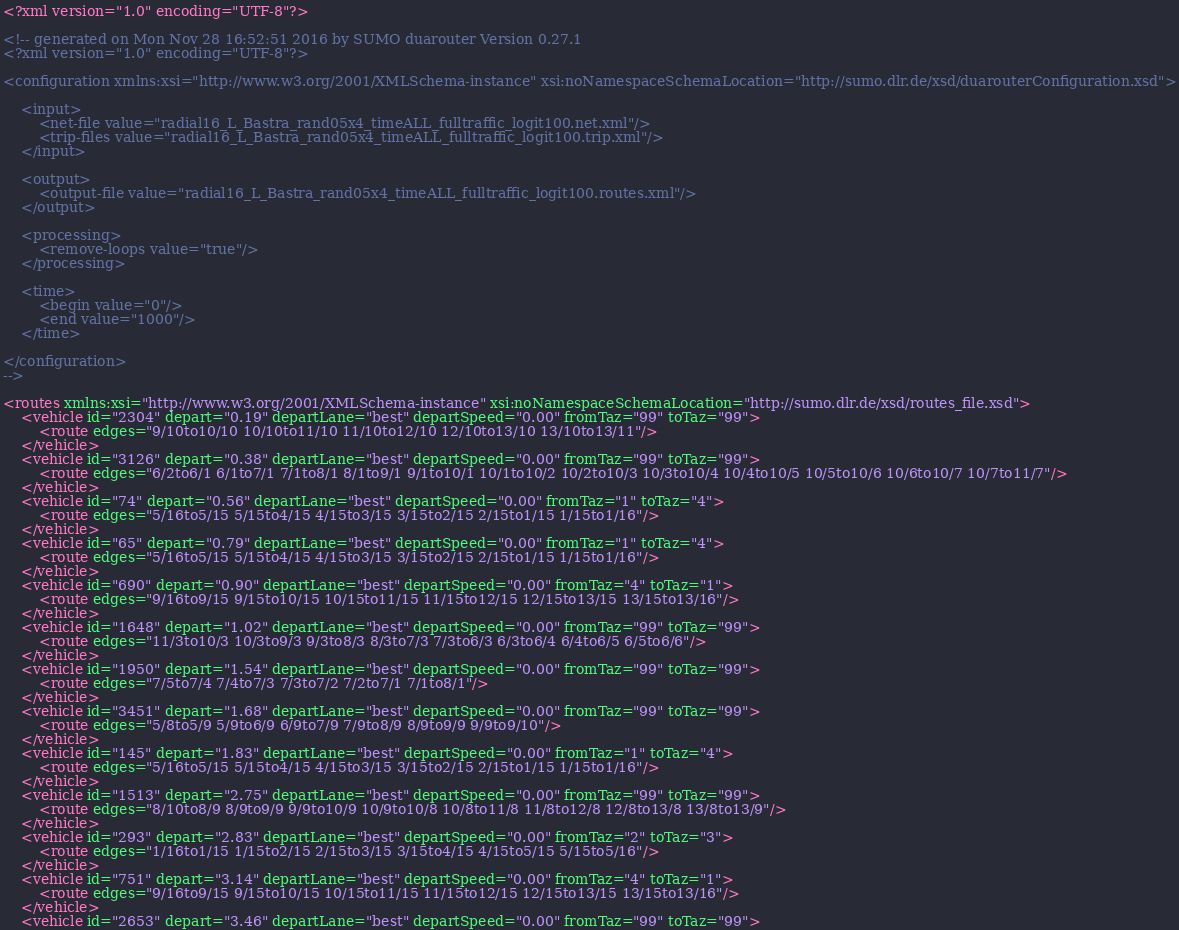Convert code to text. <code><loc_0><loc_0><loc_500><loc_500><_XML_><?xml version="1.0" encoding="UTF-8"?>

<!-- generated on Mon Nov 28 16:52:51 2016 by SUMO duarouter Version 0.27.1
<?xml version="1.0" encoding="UTF-8"?>

<configuration xmlns:xsi="http://www.w3.org/2001/XMLSchema-instance" xsi:noNamespaceSchemaLocation="http://sumo.dlr.de/xsd/duarouterConfiguration.xsd">

    <input>
        <net-file value="radial16_L_Bastra_rand05x4_timeALL_fulltraffic_logit100.net.xml"/>
        <trip-files value="radial16_L_Bastra_rand05x4_timeALL_fulltraffic_logit100.trip.xml"/>
    </input>

    <output>
        <output-file value="radial16_L_Bastra_rand05x4_timeALL_fulltraffic_logit100.routes.xml"/>
    </output>

    <processing>
        <remove-loops value="true"/>
    </processing>

    <time>
        <begin value="0"/>
        <end value="1000"/>
    </time>

</configuration>
-->

<routes xmlns:xsi="http://www.w3.org/2001/XMLSchema-instance" xsi:noNamespaceSchemaLocation="http://sumo.dlr.de/xsd/routes_file.xsd">
    <vehicle id="2304" depart="0.19" departLane="best" departSpeed="0.00" fromTaz="99" toTaz="99">
        <route edges="9/10to10/10 10/10to11/10 11/10to12/10 12/10to13/10 13/10to13/11"/>
    </vehicle>
    <vehicle id="3126" depart="0.38" departLane="best" departSpeed="0.00" fromTaz="99" toTaz="99">
        <route edges="6/2to6/1 6/1to7/1 7/1to8/1 8/1to9/1 9/1to10/1 10/1to10/2 10/2to10/3 10/3to10/4 10/4to10/5 10/5to10/6 10/6to10/7 10/7to11/7"/>
    </vehicle>
    <vehicle id="74" depart="0.56" departLane="best" departSpeed="0.00" fromTaz="1" toTaz="4">
        <route edges="5/16to5/15 5/15to4/15 4/15to3/15 3/15to2/15 2/15to1/15 1/15to1/16"/>
    </vehicle>
    <vehicle id="65" depart="0.79" departLane="best" departSpeed="0.00" fromTaz="1" toTaz="4">
        <route edges="5/16to5/15 5/15to4/15 4/15to3/15 3/15to2/15 2/15to1/15 1/15to1/16"/>
    </vehicle>
    <vehicle id="690" depart="0.90" departLane="best" departSpeed="0.00" fromTaz="4" toTaz="1">
        <route edges="9/16to9/15 9/15to10/15 10/15to11/15 11/15to12/15 12/15to13/15 13/15to13/16"/>
    </vehicle>
    <vehicle id="1648" depart="1.02" departLane="best" departSpeed="0.00" fromTaz="99" toTaz="99">
        <route edges="11/3to10/3 10/3to9/3 9/3to8/3 8/3to7/3 7/3to6/3 6/3to6/4 6/4to6/5 6/5to6/6"/>
    </vehicle>
    <vehicle id="1950" depart="1.54" departLane="best" departSpeed="0.00" fromTaz="99" toTaz="99">
        <route edges="7/5to7/4 7/4to7/3 7/3to7/2 7/2to7/1 7/1to8/1"/>
    </vehicle>
    <vehicle id="3451" depart="1.68" departLane="best" departSpeed="0.00" fromTaz="99" toTaz="99">
        <route edges="5/8to5/9 5/9to6/9 6/9to7/9 7/9to8/9 8/9to9/9 9/9to9/10"/>
    </vehicle>
    <vehicle id="145" depart="1.83" departLane="best" departSpeed="0.00" fromTaz="1" toTaz="4">
        <route edges="5/16to5/15 5/15to4/15 4/15to3/15 3/15to2/15 2/15to1/15 1/15to1/16"/>
    </vehicle>
    <vehicle id="1513" depart="2.75" departLane="best" departSpeed="0.00" fromTaz="99" toTaz="99">
        <route edges="8/10to8/9 8/9to9/9 9/9to10/9 10/9to10/8 10/8to11/8 11/8to12/8 12/8to13/8 13/8to13/9"/>
    </vehicle>
    <vehicle id="293" depart="2.83" departLane="best" departSpeed="0.00" fromTaz="2" toTaz="3">
        <route edges="1/16to1/15 1/15to2/15 2/15to3/15 3/15to4/15 4/15to5/15 5/15to5/16"/>
    </vehicle>
    <vehicle id="751" depart="3.14" departLane="best" departSpeed="0.00" fromTaz="4" toTaz="1">
        <route edges="9/16to9/15 9/15to10/15 10/15to11/15 11/15to12/15 12/15to13/15 13/15to13/16"/>
    </vehicle>
    <vehicle id="2653" depart="3.46" departLane="best" departSpeed="0.00" fromTaz="99" toTaz="99"></code> 